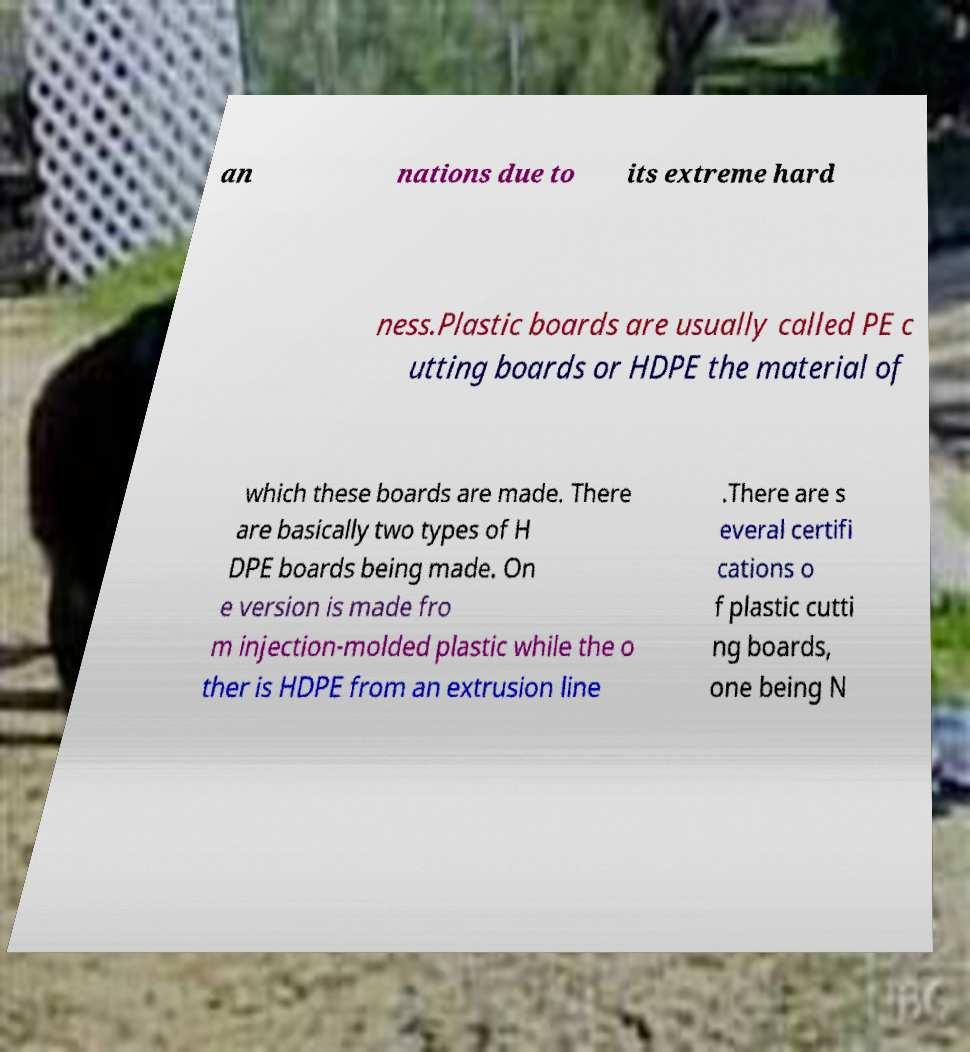Can you read and provide the text displayed in the image?This photo seems to have some interesting text. Can you extract and type it out for me? an nations due to its extreme hard ness.Plastic boards are usually called PE c utting boards or HDPE the material of which these boards are made. There are basically two types of H DPE boards being made. On e version is made fro m injection-molded plastic while the o ther is HDPE from an extrusion line .There are s everal certifi cations o f plastic cutti ng boards, one being N 